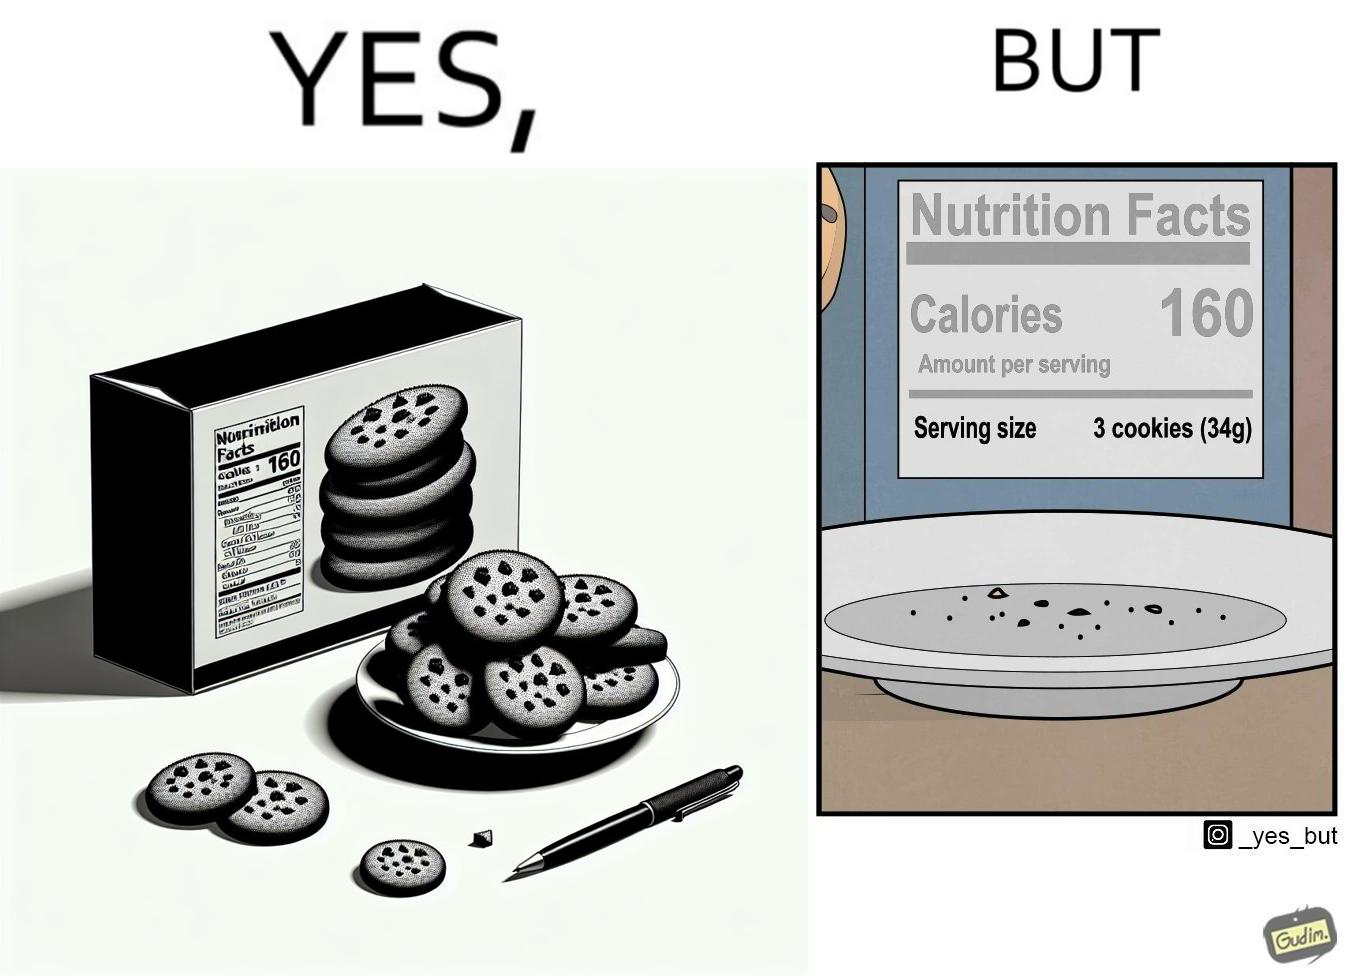Is this image satirical or non-satirical? Yes, this image is satirical. 